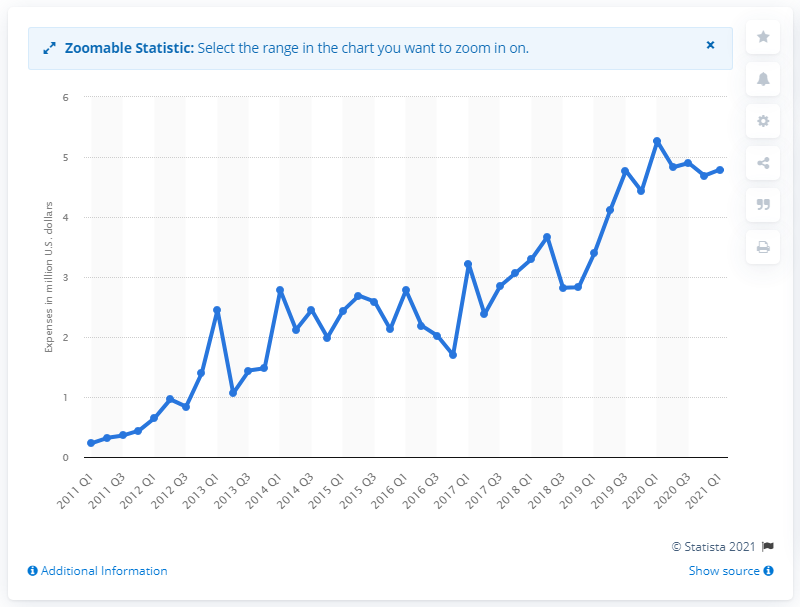List a handful of essential elements in this visual. Facebook spent 4.79 million dollars lobbying in the United States in the first quarter of 2021. Facebook spent approximately $5.26 billion in the first quarter of 2020. 